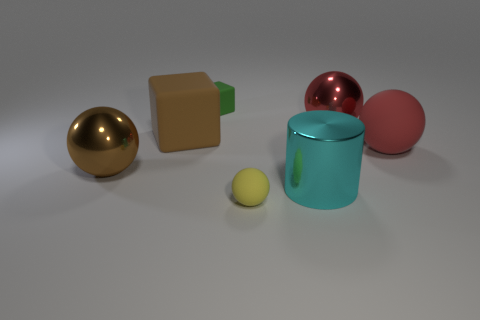What is the shape of the large metal object that is the same color as the large matte cube?
Offer a terse response. Sphere. There is a sphere left of the large rubber block; what size is it?
Your answer should be compact. Large. Do the red matte ball and the yellow ball have the same size?
Your response must be concise. No. How many objects are brown metal spheres or big spheres behind the big brown sphere?
Offer a very short reply. 3. What material is the large brown ball?
Offer a very short reply. Metal. Is there any other thing that has the same color as the large rubber sphere?
Keep it short and to the point. Yes. Does the yellow thing have the same shape as the big red matte thing?
Make the answer very short. Yes. What size is the rubber object to the right of the tiny matte object that is in front of the big ball that is on the left side of the brown block?
Provide a short and direct response. Large. How many other objects are the same material as the large brown block?
Your answer should be compact. 3. The small rubber object that is behind the red matte sphere is what color?
Your answer should be very brief. Green. 